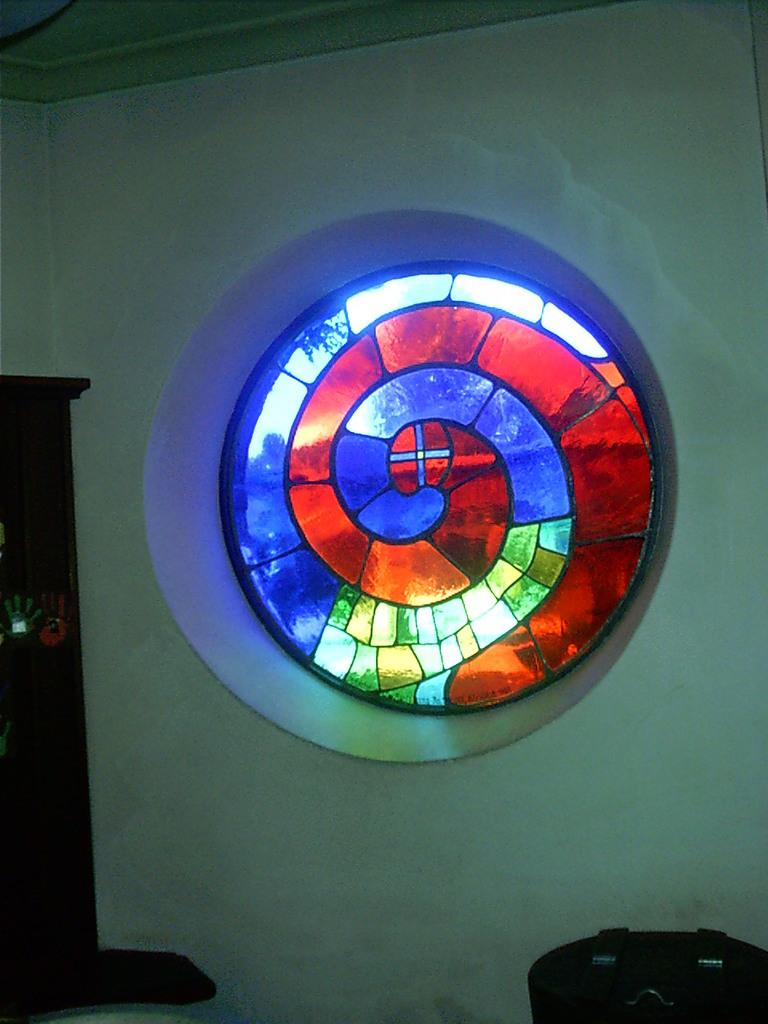What type of decoration is on the wall in the image? There is a stained glass on the wall in the image. Where is the table located in the image? The table is in the bottom right-hand corner of the image. What type of furniture is on the left side of the image? There is a cupboard on the left side of the image. Can you tell me how many frogs are playing on the table in the image? There are no frogs present in the image, and they are not playing on the table. What type of joke is depicted in the stained glass in the image? There is no joke depicted in the stained glass in the image; it is a decorative piece of art. 